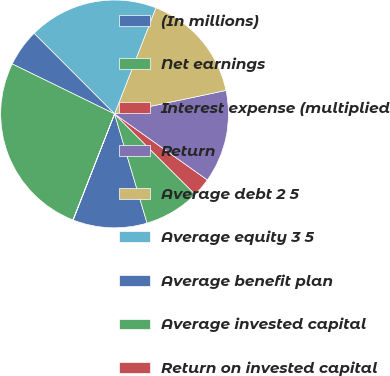Convert chart to OTSL. <chart><loc_0><loc_0><loc_500><loc_500><pie_chart><fcel>(In millions)<fcel>Net earnings<fcel>Interest expense (multiplied<fcel>Return<fcel>Average debt 2 5<fcel>Average equity 3 5<fcel>Average benefit plan<fcel>Average invested capital<fcel>Return on invested capital<nl><fcel>10.53%<fcel>7.9%<fcel>2.65%<fcel>13.15%<fcel>15.78%<fcel>18.4%<fcel>5.28%<fcel>26.28%<fcel>0.03%<nl></chart> 